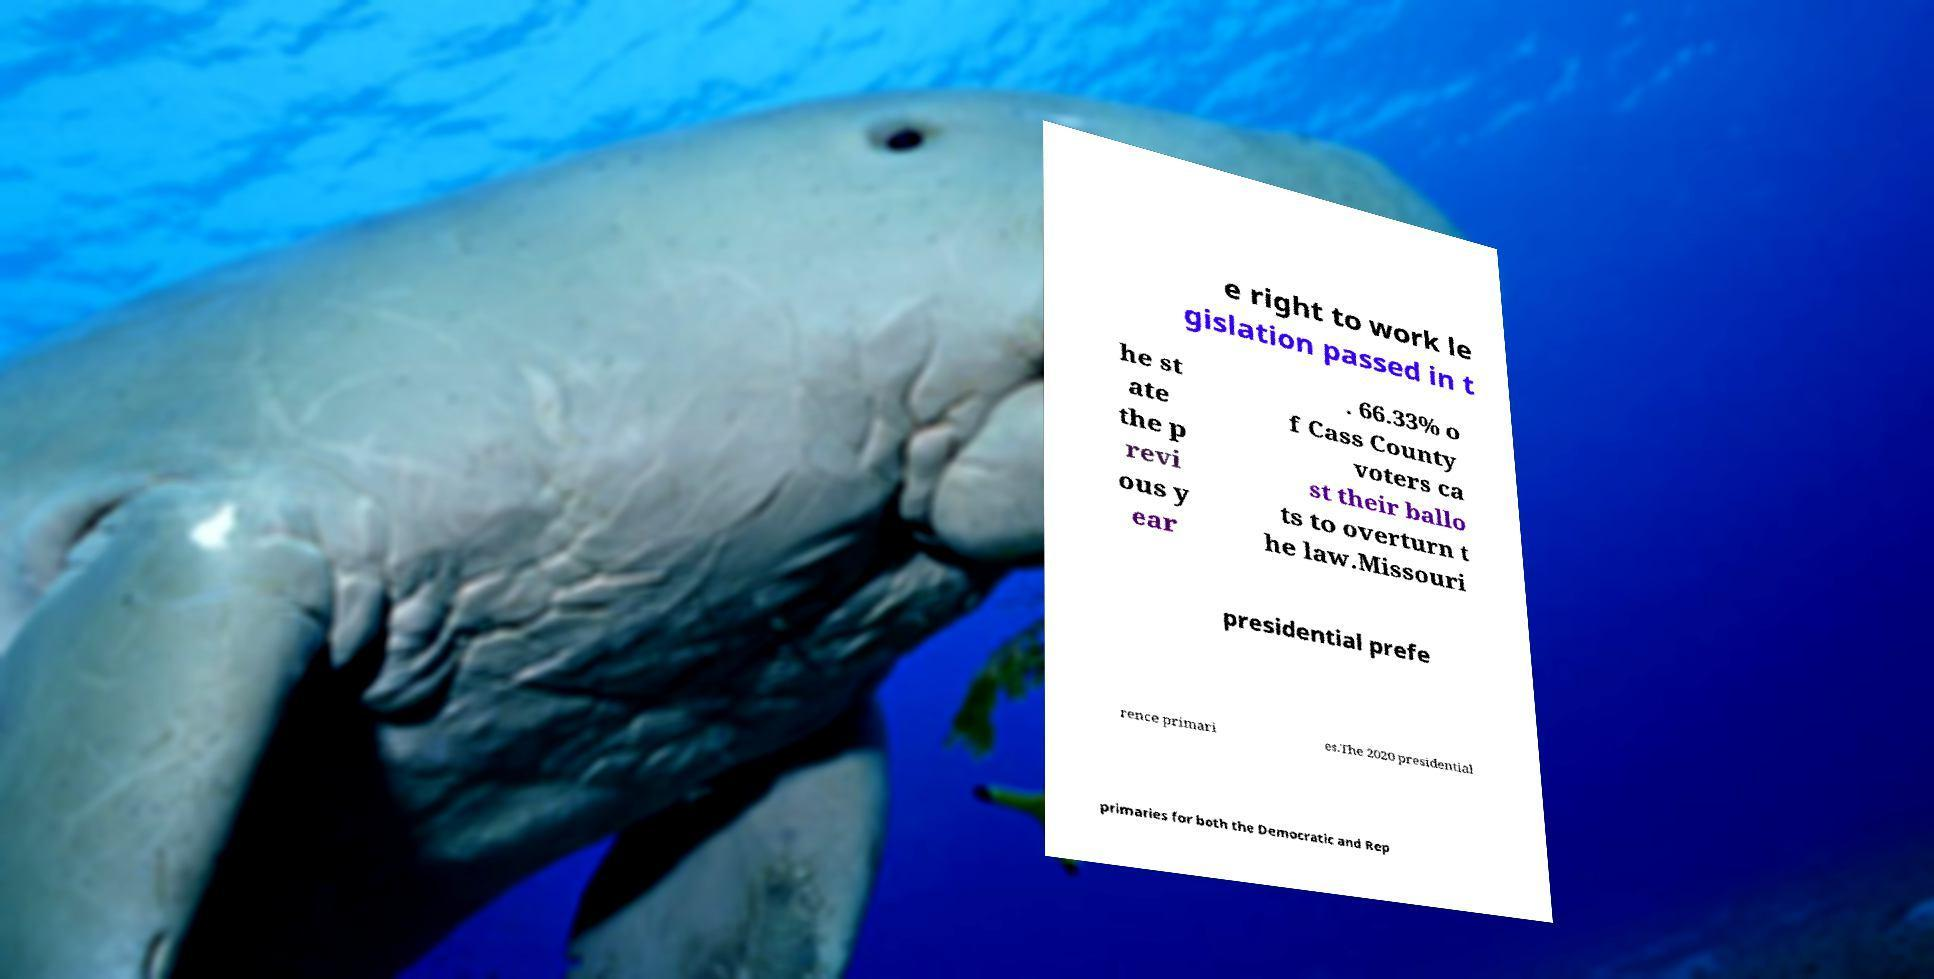I need the written content from this picture converted into text. Can you do that? e right to work le gislation passed in t he st ate the p revi ous y ear . 66.33% o f Cass County voters ca st their ballo ts to overturn t he law.Missouri presidential prefe rence primari es.The 2020 presidential primaries for both the Democratic and Rep 